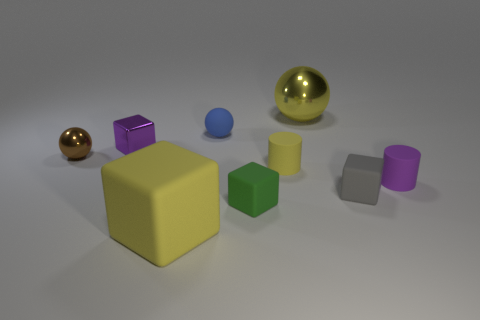Add 1 brown metallic balls. How many objects exist? 10 Subtract all blocks. How many objects are left? 5 Subtract all green metallic objects. Subtract all gray rubber objects. How many objects are left? 8 Add 1 tiny purple rubber cylinders. How many tiny purple rubber cylinders are left? 2 Add 5 small purple things. How many small purple things exist? 7 Subtract 1 brown spheres. How many objects are left? 8 